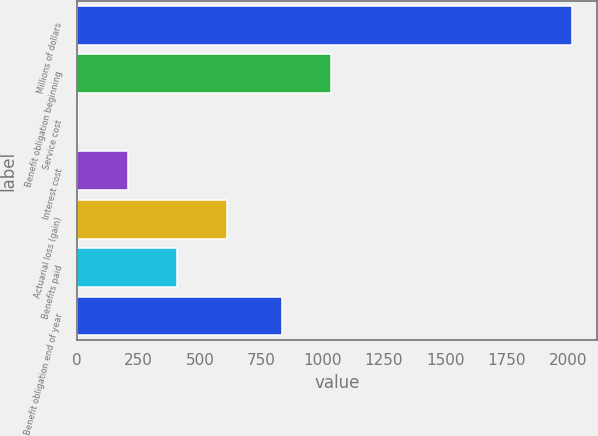Convert chart. <chart><loc_0><loc_0><loc_500><loc_500><bar_chart><fcel>Millions of dollars<fcel>Benefit obligation beginning<fcel>Service cost<fcel>Interest cost<fcel>Actuarial loss (gain)<fcel>Benefits paid<fcel>Benefit obligation end of year<nl><fcel>2018<fcel>1035.3<fcel>5<fcel>206.3<fcel>608.9<fcel>407.6<fcel>834<nl></chart> 